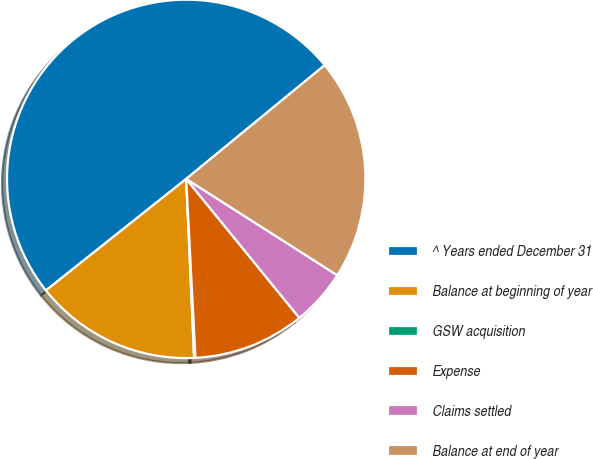<chart> <loc_0><loc_0><loc_500><loc_500><pie_chart><fcel>^ Years ended December 31<fcel>Balance at beginning of year<fcel>GSW acquisition<fcel>Expense<fcel>Claims settled<fcel>Balance at end of year<nl><fcel>49.75%<fcel>15.01%<fcel>0.12%<fcel>10.05%<fcel>5.09%<fcel>19.98%<nl></chart> 